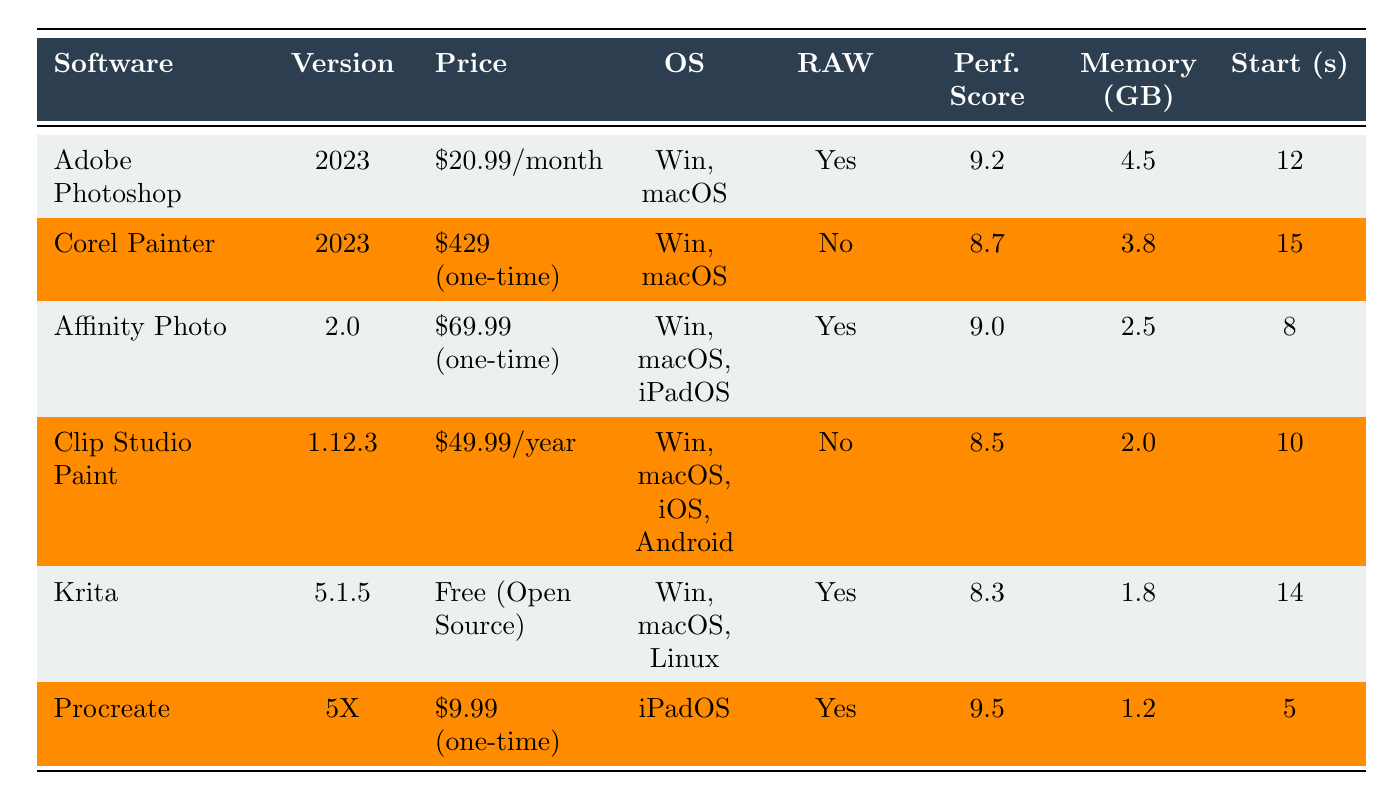What is the price of Corel Painter? The price of Corel Painter is listed directly in the table, which shows it as "$429 (one-time)".
Answer: $429 (one-time) Which software has the highest performance score? By comparing the performance scores listed in the table, Procreate has the highest score at 9.5.
Answer: Procreate Is RAW support available in Clip Studio Paint? The table indicates that Clip Studio Paint does not have RAW support, as it shows "No" in the corresponding column.
Answer: No What is the average memory usage of the listed software? To find the average memory usage, add all memory values: 4.5 + 3.8 + 2.5 + 2.0 + 1.8 + 1.2 = 15.8 GB. There are 6 software; thus, the average is 15.8/6 = 2.63 GB.
Answer: 2.63 GB How much faster is Procreate's startup time compared to Adobe Photoshop? Procreate's startup time is 5 seconds, while Adobe Photoshop's is 12 seconds. The difference is 12 - 5 = 7 seconds, making Procreate faster by that duration.
Answer: 7 seconds Which software offers extensive brush customization? The table shows that both Adobe Photoshop and Krita offer extensive brush customization, as categorized under their respective columns.
Answer: Adobe Photoshop and Krita Is Affinity Photo available on iPadOS? The software list indicates that Affinity Photo is available on Windows, macOS, and iPadOS, confirming that it does support iPadOS.
Answer: Yes What is the memory usage difference between Corel Painter and Krita? From the table, Corel Painter uses 3.8 GB and Krita uses 1.8 GB. The difference is 3.8 - 1.8 = 2.0 GB.
Answer: 2.0 GB How many software options listed support RAW files? According to the table, the software that supports RAW files are Adobe Photoshop, Affinity Photo, Krita, and Procreate, totaling to 4 options.
Answer: 4 If you had to choose between the software based solely on startup time and performance score, which would be the best option? Procreate has a startup time of 5 seconds and a performance score of 9.5, both of which are the best in their categories compared to others, making it the best overall based on these criteria.
Answer: Procreate 